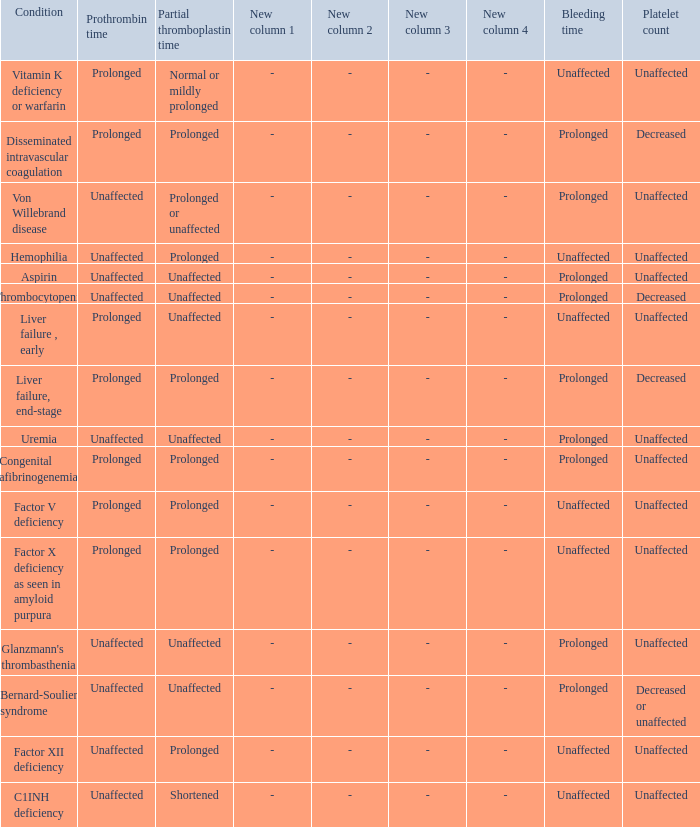What disorder exhibits a normal partial thromboplastin time, platelet count, and prothrombin time? Aspirin, Uremia, Glanzmann's thrombasthenia. Can you parse all the data within this table? {'header': ['Condition', 'Prothrombin time', 'Partial thromboplastin time', 'New column 1', 'New column 2', 'New column 3', 'New column 4', 'Bleeding time', 'Platelet count'], 'rows': [['Vitamin K deficiency or warfarin', 'Prolonged', 'Normal or mildly prolonged', '-', '-', '-', '-', 'Unaffected', 'Unaffected'], ['Disseminated intravascular coagulation', 'Prolonged', 'Prolonged', '-', '-', '-', '-', 'Prolonged', 'Decreased'], ['Von Willebrand disease', 'Unaffected', 'Prolonged or unaffected', '-', '-', '-', '-', 'Prolonged', 'Unaffected'], ['Hemophilia', 'Unaffected', 'Prolonged', '-', '-', '-', '-', 'Unaffected', 'Unaffected'], ['Aspirin', 'Unaffected', 'Unaffected', '-', '-', '-', '-', 'Prolonged', 'Unaffected'], ['Thrombocytopenia', 'Unaffected', 'Unaffected', '-', '-', '-', '-', 'Prolonged', 'Decreased'], ['Liver failure , early', 'Prolonged', 'Unaffected', '-', '-', '-', '-', 'Unaffected', 'Unaffected'], ['Liver failure, end-stage', 'Prolonged', 'Prolonged', '-', '-', '-', '-', 'Prolonged', 'Decreased'], ['Uremia', 'Unaffected', 'Unaffected', '-', '-', '-', '-', 'Prolonged', 'Unaffected'], ['Congenital afibrinogenemia', 'Prolonged', 'Prolonged', '-', '-', '-', '-', 'Prolonged', 'Unaffected'], ['Factor V deficiency', 'Prolonged', 'Prolonged', '-', '-', '-', '-', 'Unaffected', 'Unaffected'], ['Factor X deficiency as seen in amyloid purpura', 'Prolonged', 'Prolonged', '-', '-', '-', '-', 'Unaffected', 'Unaffected'], ["Glanzmann's thrombasthenia", 'Unaffected', 'Unaffected', '-', '-', '-', '-', 'Prolonged', 'Unaffected'], ['Bernard-Soulier syndrome', 'Unaffected', 'Unaffected', '-', '-', '-', '-', 'Prolonged', 'Decreased or unaffected'], ['Factor XII deficiency', 'Unaffected', 'Prolonged', '-', '-', '-', '-', 'Unaffected', 'Unaffected'], ['C1INH deficiency', 'Unaffected', 'Shortened', '-', '-', '-', '-', 'Unaffected', 'Unaffected']]} 